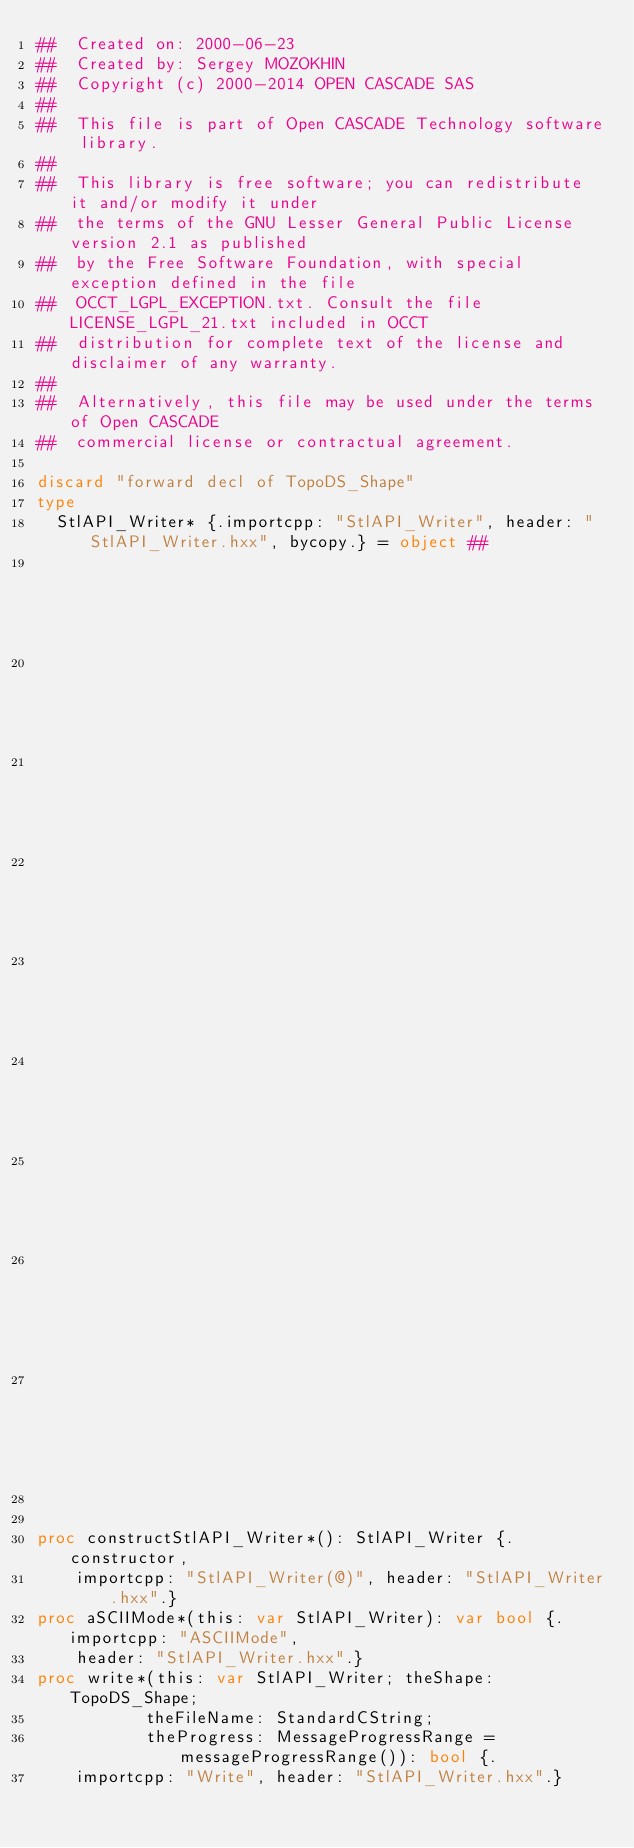Convert code to text. <code><loc_0><loc_0><loc_500><loc_500><_Nim_>##  Created on: 2000-06-23
##  Created by: Sergey MOZOKHIN
##  Copyright (c) 2000-2014 OPEN CASCADE SAS
##
##  This file is part of Open CASCADE Technology software library.
##
##  This library is free software; you can redistribute it and/or modify it under
##  the terms of the GNU Lesser General Public License version 2.1 as published
##  by the Free Software Foundation, with special exception defined in the file
##  OCCT_LGPL_EXCEPTION.txt. Consult the file LICENSE_LGPL_21.txt included in OCCT
##  distribution for complete text of the license and disclaimer of any warranty.
##
##  Alternatively, this file may be used under the terms of Open CASCADE
##  commercial license or contractual agreement.

discard "forward decl of TopoDS_Shape"
type
  StlAPI_Writer* {.importcpp: "StlAPI_Writer", header: "StlAPI_Writer.hxx", bycopy.} = object ##
                                                                                      ## !
                                                                                      ## Creates
                                                                                      ## a
                                                                                      ## writer
                                                                                      ## object
                                                                                      ## with
                                                                                      ## default
                                                                                      ## parameters:
                                                                                      ## ASCIIMode.


proc constructStlAPI_Writer*(): StlAPI_Writer {.constructor,
    importcpp: "StlAPI_Writer(@)", header: "StlAPI_Writer.hxx".}
proc aSCIIMode*(this: var StlAPI_Writer): var bool {.importcpp: "ASCIIMode",
    header: "StlAPI_Writer.hxx".}
proc write*(this: var StlAPI_Writer; theShape: TopoDS_Shape;
           theFileName: StandardCString;
           theProgress: MessageProgressRange = messageProgressRange()): bool {.
    importcpp: "Write", header: "StlAPI_Writer.hxx".}

























</code> 